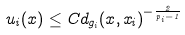Convert formula to latex. <formula><loc_0><loc_0><loc_500><loc_500>u _ { i } ( x ) \leq C d _ { g _ { i } } ( x , x _ { i } ) ^ { - \frac { 2 } { p _ { i } - 1 } }</formula> 